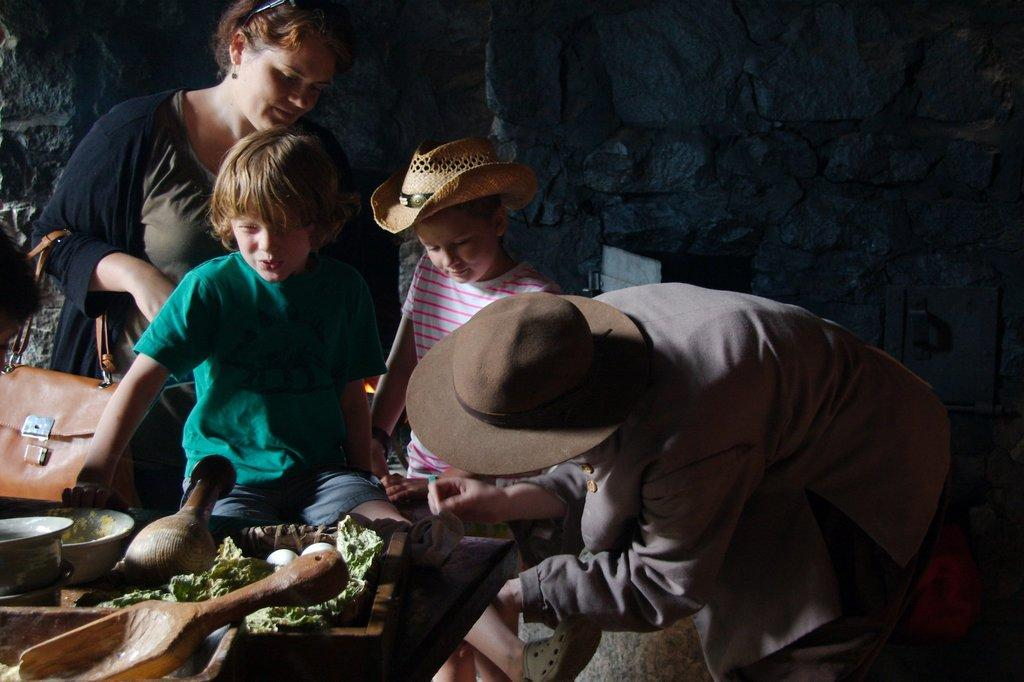How many people are in the image? There is a group of people in the image, but the exact number cannot be determined from the provided facts. What is on the table in the image? There are utensils, a ladle, and eggs on the table in the image. What can be seen in the background of the image? There are walls in the background of the image. How many ants are crawling on the eggs in the image? There are no ants present in the image; only a group of people, a table, utensils, a ladle, and eggs are visible. What shape is the quince on the table in the image? There is no quince present in the image; only a group of people, a table, utensils, a ladle, and eggs are visible. 